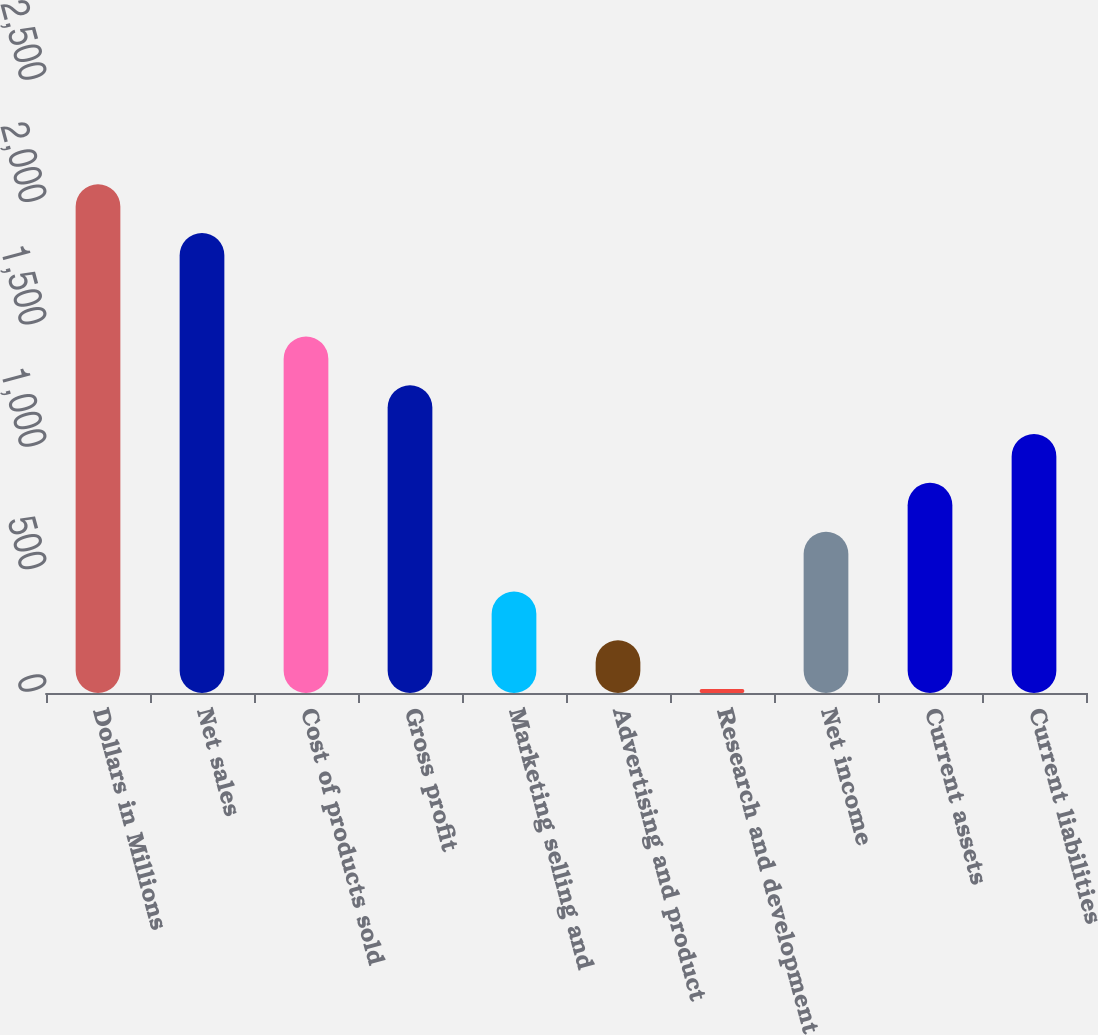<chart> <loc_0><loc_0><loc_500><loc_500><bar_chart><fcel>Dollars in Millions<fcel>Net sales<fcel>Cost of products sold<fcel>Gross profit<fcel>Marketing selling and<fcel>Advertising and product<fcel>Research and development<fcel>Net income<fcel>Current assets<fcel>Current liabilities<nl><fcel>2078.4<fcel>1879<fcel>1456.6<fcel>1257.2<fcel>414.8<fcel>215.4<fcel>16<fcel>659<fcel>858.4<fcel>1057.8<nl></chart> 